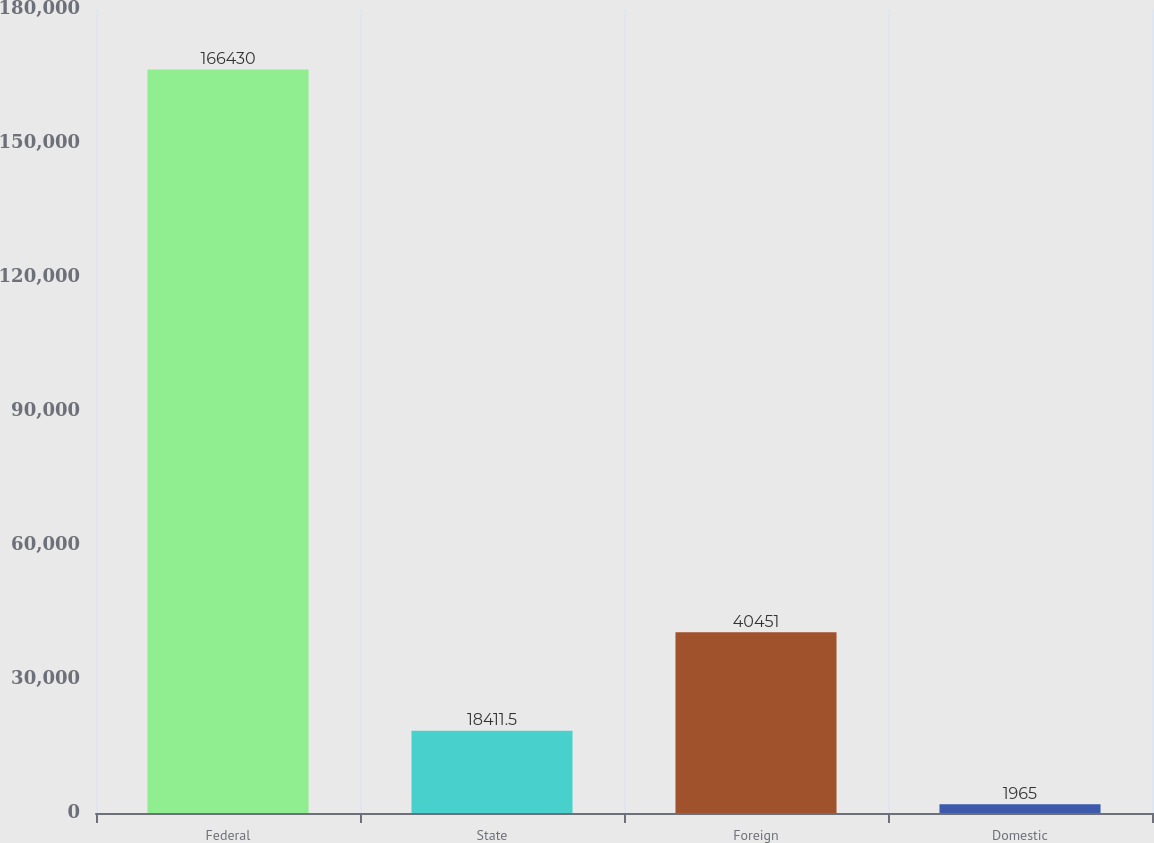Convert chart. <chart><loc_0><loc_0><loc_500><loc_500><bar_chart><fcel>Federal<fcel>State<fcel>Foreign<fcel>Domestic<nl><fcel>166430<fcel>18411.5<fcel>40451<fcel>1965<nl></chart> 